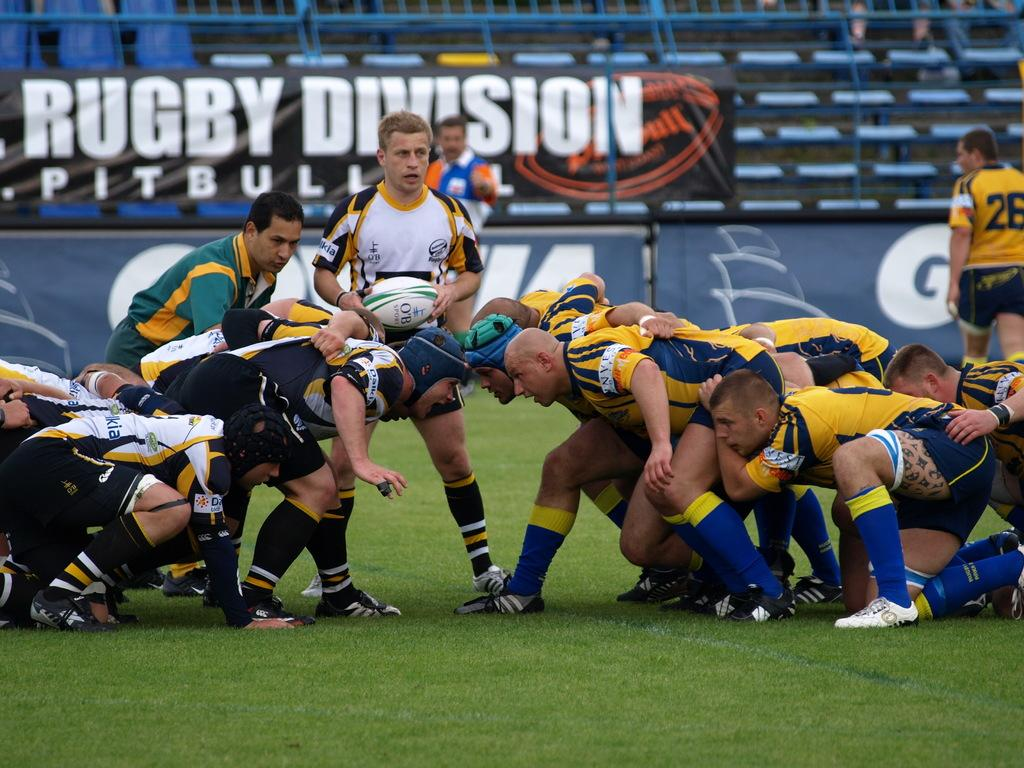<image>
Describe the image concisely. A rugby game takes place in front of a banner that says Rugby Division Pitbull. 